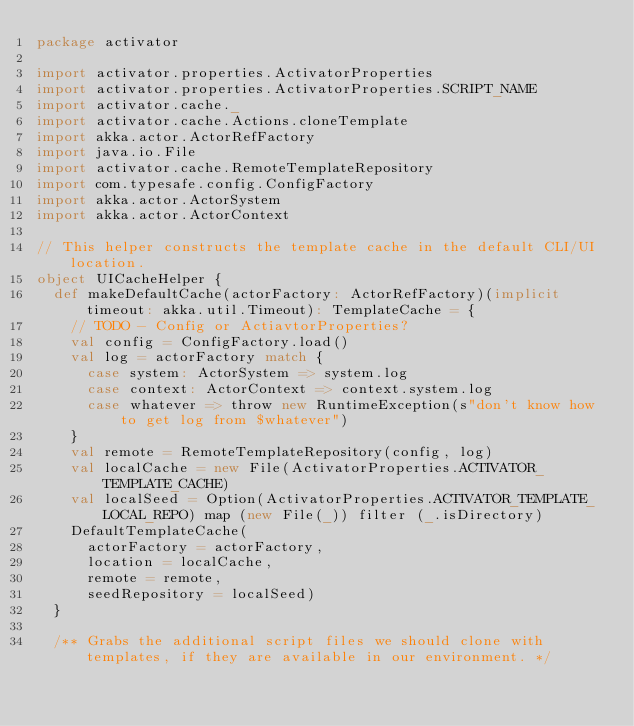Convert code to text. <code><loc_0><loc_0><loc_500><loc_500><_Scala_>package activator

import activator.properties.ActivatorProperties
import activator.properties.ActivatorProperties.SCRIPT_NAME
import activator.cache._
import activator.cache.Actions.cloneTemplate
import akka.actor.ActorRefFactory
import java.io.File
import activator.cache.RemoteTemplateRepository
import com.typesafe.config.ConfigFactory
import akka.actor.ActorSystem
import akka.actor.ActorContext

// This helper constructs the template cache in the default CLI/UI location.
object UICacheHelper {
  def makeDefaultCache(actorFactory: ActorRefFactory)(implicit timeout: akka.util.Timeout): TemplateCache = {
    // TODO - Config or ActiavtorProperties?
    val config = ConfigFactory.load()
    val log = actorFactory match {
      case system: ActorSystem => system.log
      case context: ActorContext => context.system.log
      case whatever => throw new RuntimeException(s"don't know how to get log from $whatever")
    }
    val remote = RemoteTemplateRepository(config, log)
    val localCache = new File(ActivatorProperties.ACTIVATOR_TEMPLATE_CACHE)
    val localSeed = Option(ActivatorProperties.ACTIVATOR_TEMPLATE_LOCAL_REPO) map (new File(_)) filter (_.isDirectory)
    DefaultTemplateCache(
      actorFactory = actorFactory,
      location = localCache,
      remote = remote,
      seedRepository = localSeed)
  }

  /** Grabs the additional script files we should clone with templates, if they are available in our environment. */</code> 